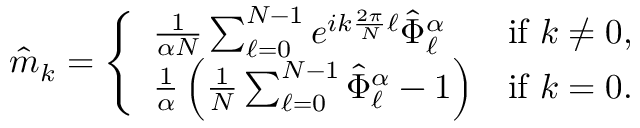<formula> <loc_0><loc_0><loc_500><loc_500>\hat { m } _ { k } = \left \{ \begin{array} { l l } { \frac { 1 } { \alpha N } \sum _ { \ell = 0 } ^ { N - 1 } e ^ { i k \frac { 2 \pi } { N } \ell } \hat { \Phi } _ { \ell } ^ { \alpha } } & { i f k \neq 0 , } \\ { \frac { 1 } { \alpha } \left ( \frac { 1 } { N } \sum _ { \ell = 0 } ^ { N - 1 } \hat { \Phi } _ { \ell } ^ { \alpha } - 1 \right ) } & { i f k = 0 . } \end{array}</formula> 